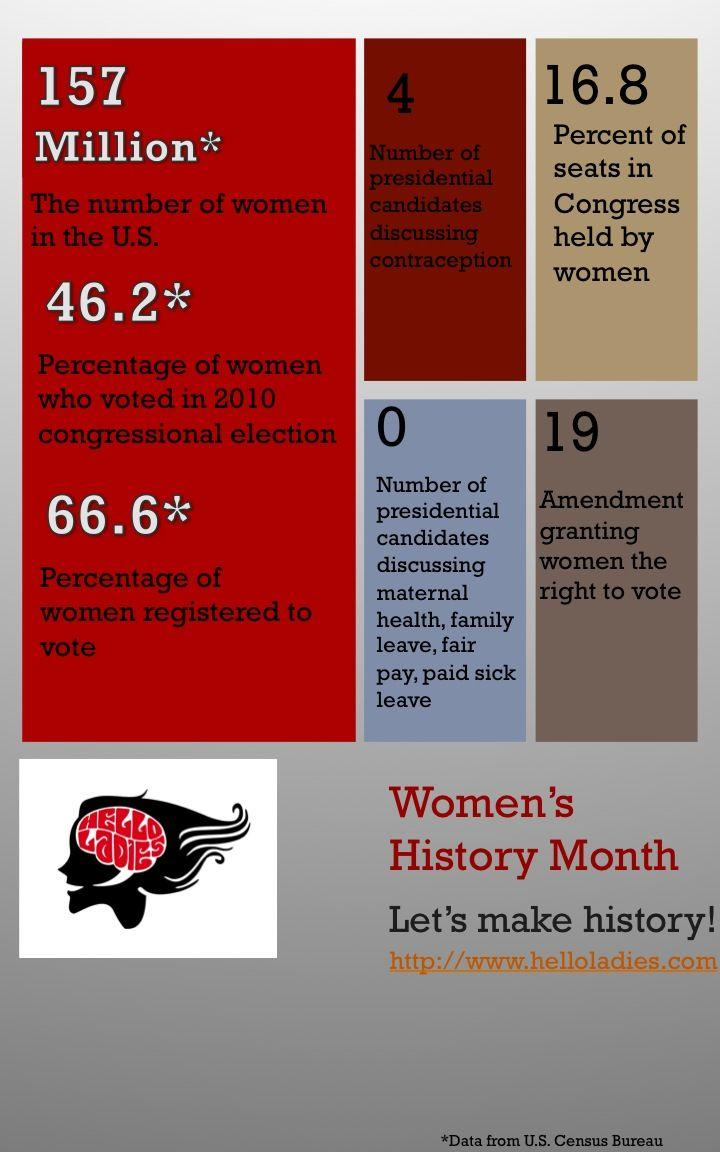List a handful of essential elements in this visual. According to recent estimates, there are approximately 157 million women living in the United States. The 19th Amendment to the United States Constitution granted women the right to vote in the United States. Four presidential candidates are currently discussing contraception. According to the official records, 66.6% of eligible women have registered to vote in the upcoming election. Although some presidential candidates have been discussing issues such as maternal health, fair pay, and paid sick leave, none of them have been actively advocating for these causes. 